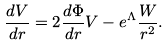Convert formula to latex. <formula><loc_0><loc_0><loc_500><loc_500>\frac { d V } { d r } = 2 \frac { d \Phi } { d r } V - e ^ { \Lambda } \frac { W } { r ^ { 2 } } .</formula> 